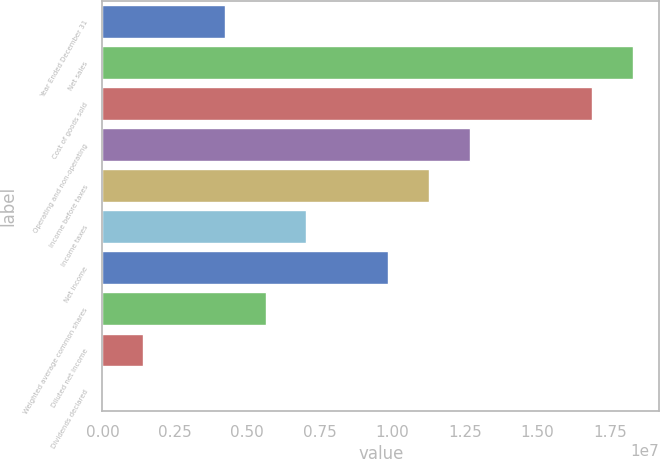<chart> <loc_0><loc_0><loc_500><loc_500><bar_chart><fcel>Year Ended December 31<fcel>Net sales<fcel>Cost of goods sold<fcel>Operating and non-operating<fcel>Income before taxes<fcel>Income taxes<fcel>Net income<fcel>Weighted average common shares<fcel>Diluted net income<fcel>Dividends declared<nl><fcel>4.22335e+06<fcel>1.83012e+07<fcel>1.68934e+07<fcel>1.26701e+07<fcel>1.12623e+07<fcel>7.03892e+06<fcel>9.85449e+06<fcel>5.63114e+06<fcel>1.40779e+06<fcel>2.15<nl></chart> 